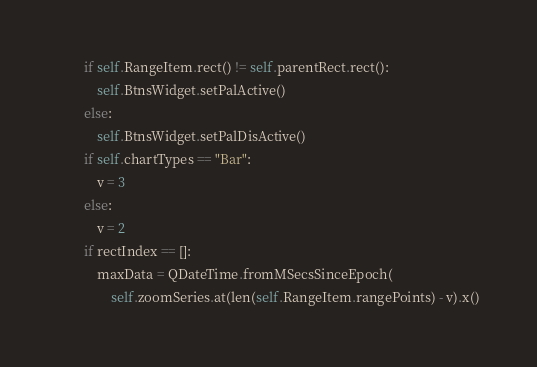Convert code to text. <code><loc_0><loc_0><loc_500><loc_500><_Python_>
        if self.RangeItem.rect() != self.parentRect.rect():
            self.BtnsWidget.setPalActive()
        else:
            self.BtnsWidget.setPalDisActive()
        if self.chartTypes == "Bar":
            v = 3
        else:
            v = 2
        if rectIndex == []:
            maxData = QDateTime.fromMSecsSinceEpoch(
                self.zoomSeries.at(len(self.RangeItem.rangePoints) - v).x()</code> 